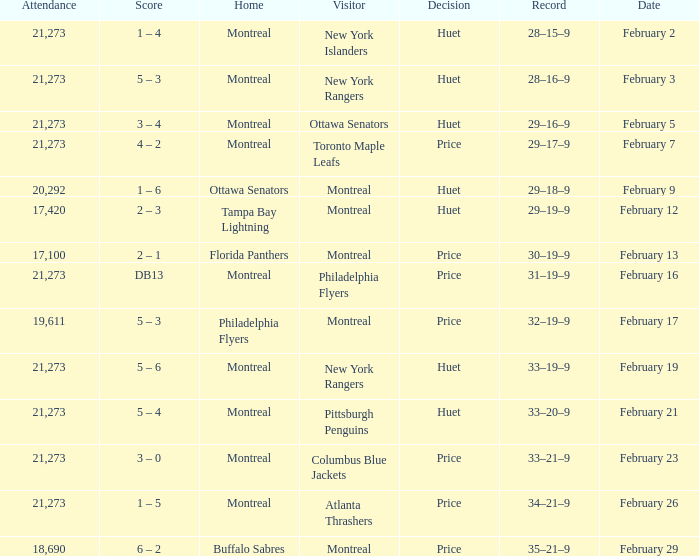What was the date of the game when the Canadiens had a record of 31–19–9? February 16. 